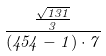Convert formula to latex. <formula><loc_0><loc_0><loc_500><loc_500>\frac { \frac { \sqrt { 1 3 1 } } { 3 } } { ( 4 5 4 - 1 ) \cdot 7 }</formula> 